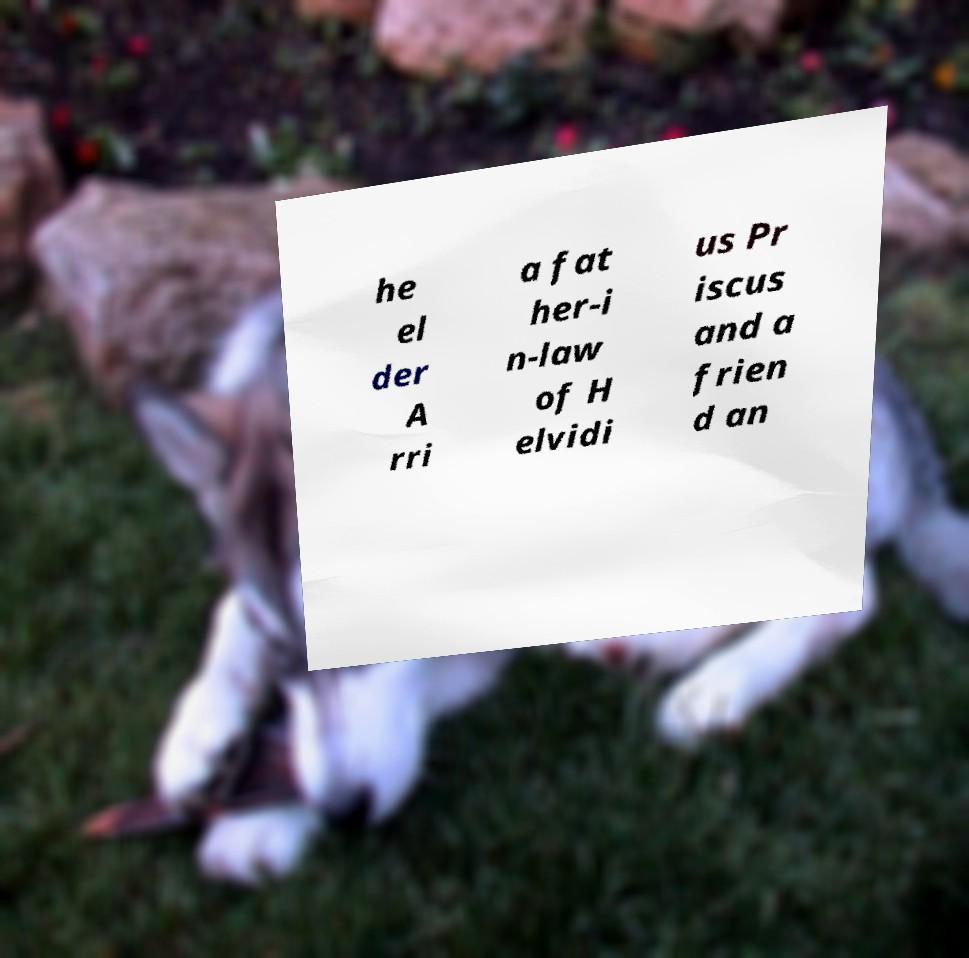Please identify and transcribe the text found in this image. he el der A rri a fat her-i n-law of H elvidi us Pr iscus and a frien d an 